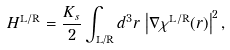<formula> <loc_0><loc_0><loc_500><loc_500>H ^ { \text {L} / \text {R} } = \frac { K _ { s } } { 2 } \int _ { \text {L/R} } d ^ { 3 } r \, \left | \nabla \chi ^ { \text {L} / \text {R} } ( { r } ) \right | ^ { 2 } ,</formula> 